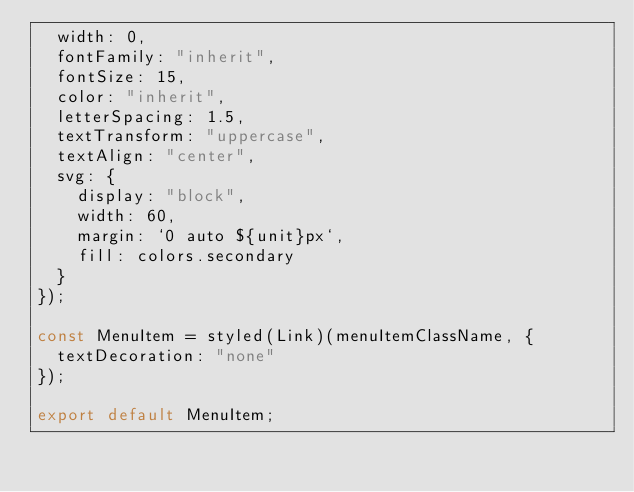<code> <loc_0><loc_0><loc_500><loc_500><_JavaScript_>  width: 0,
  fontFamily: "inherit",
  fontSize: 15,
  color: "inherit",
  letterSpacing: 1.5,
  textTransform: "uppercase",
  textAlign: "center",
  svg: {
    display: "block",
    width: 60,
    margin: `0 auto ${unit}px`,
    fill: colors.secondary
  }
});

const MenuItem = styled(Link)(menuItemClassName, {
  textDecoration: "none"
});

export default MenuItem;
</code> 